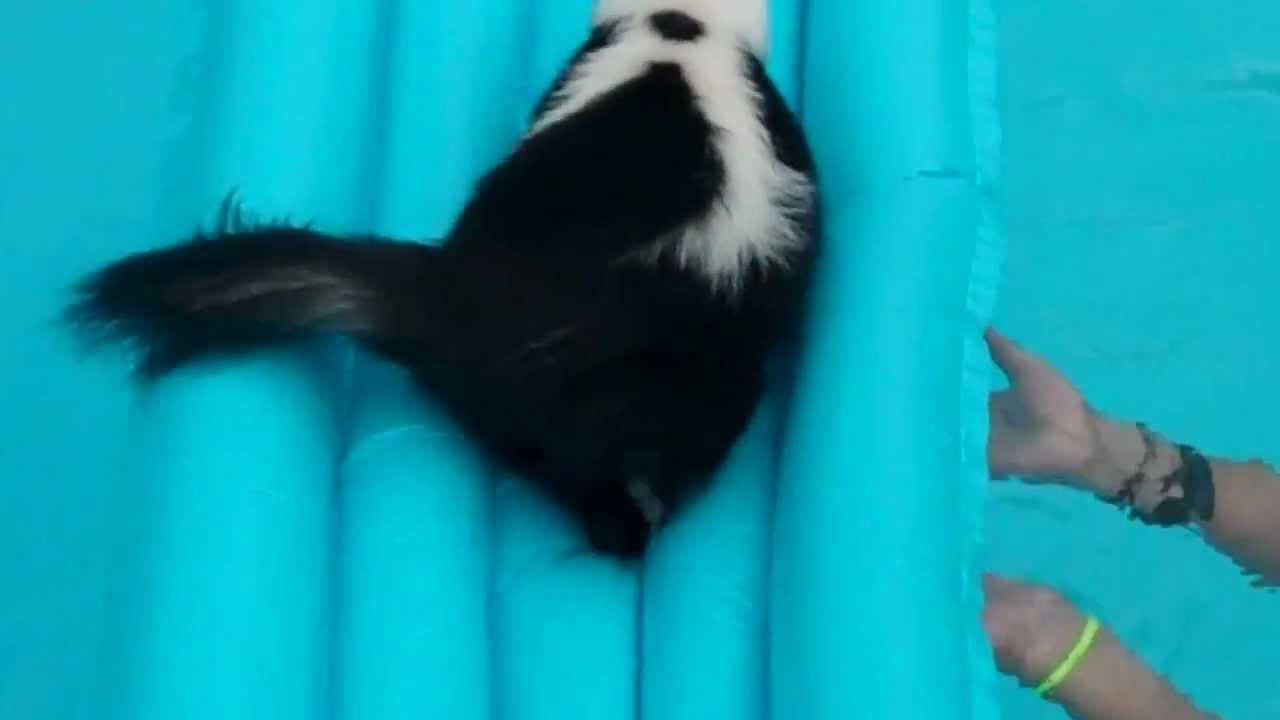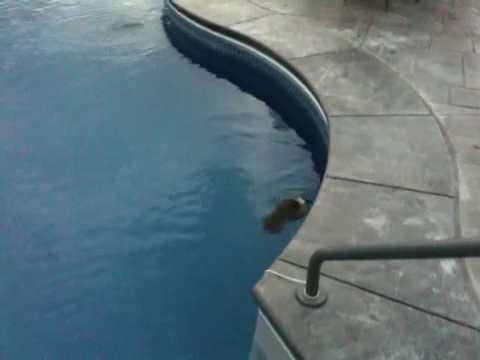The first image is the image on the left, the second image is the image on the right. Examine the images to the left and right. Is the description "In at least one image there is a skunk sitting on a blue raft in a pool." accurate? Answer yes or no. Yes. The first image is the image on the left, the second image is the image on the right. For the images shown, is this caption "The skunk in one of the images is sitting on a float in a pool, while in the other image it is swimming freely in the water." true? Answer yes or no. Yes. 